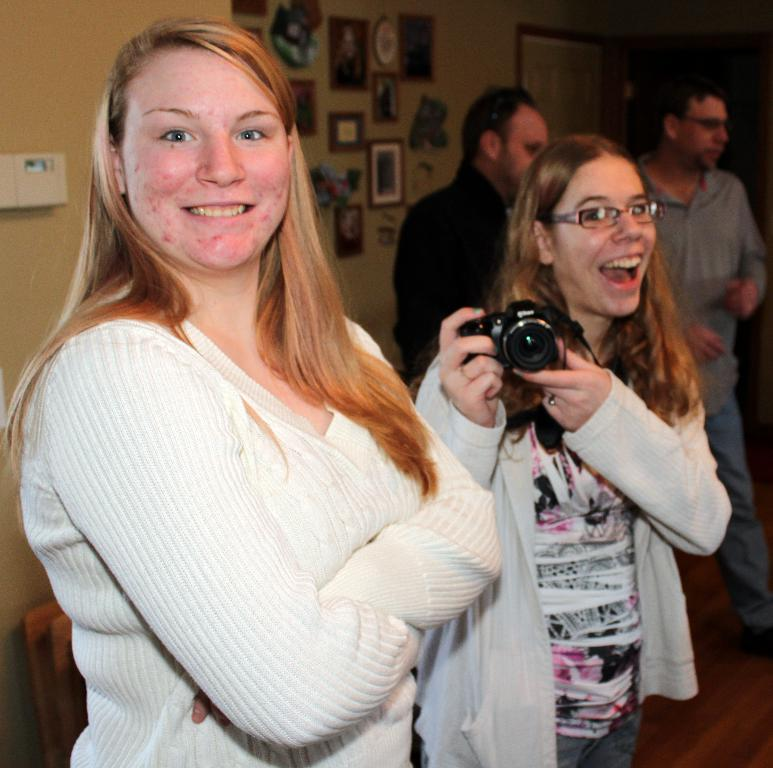How many people are in the image? There are 2 girls and 2 men in the image, making a total of 4 people. What are the girls doing in the image? The girls are smiling, and one of them is holding a camera. What can be seen in the background of the image? There is a wall in the background of the image, and there are objects on the wall. What are the men doing in the image? The information provided does not specify what the men are doing in the image. What type of pain can be seen on the girls' faces in the image? There is no indication of pain on the girls' faces in the image; they are smiling. What kind of cable is connecting the camera to the wall in the image? There is no cable connecting the camera to the wall in the image; the girl is holding the camera. 